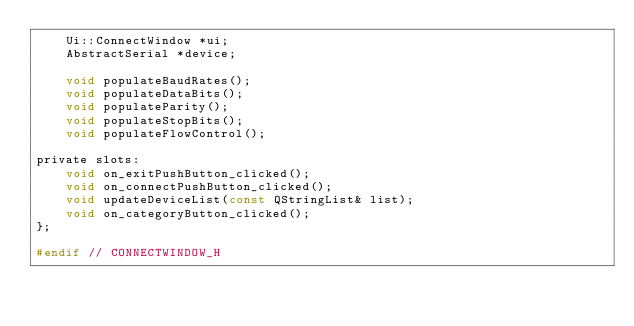<code> <loc_0><loc_0><loc_500><loc_500><_C_>    Ui::ConnectWindow *ui;
    AbstractSerial *device;

    void populateBaudRates();
    void populateDataBits();
    void populateParity();
    void populateStopBits();
    void populateFlowControl();

private slots:
    void on_exitPushButton_clicked();
    void on_connectPushButton_clicked();
    void updateDeviceList(const QStringList& list);
    void on_categoryButton_clicked();
};

#endif // CONNECTWINDOW_H
</code> 